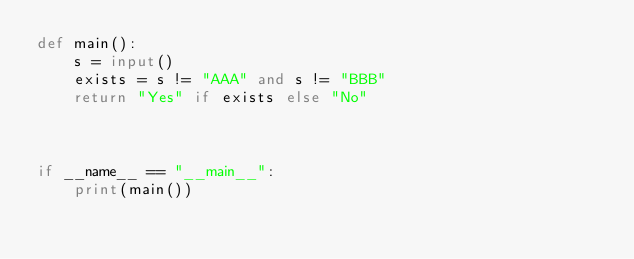Convert code to text. <code><loc_0><loc_0><loc_500><loc_500><_Python_>def main():
    s = input()
    exists = s != "AAA" and s != "BBB"
    return "Yes" if exists else "No"
    


if __name__ == "__main__":
    print(main())</code> 